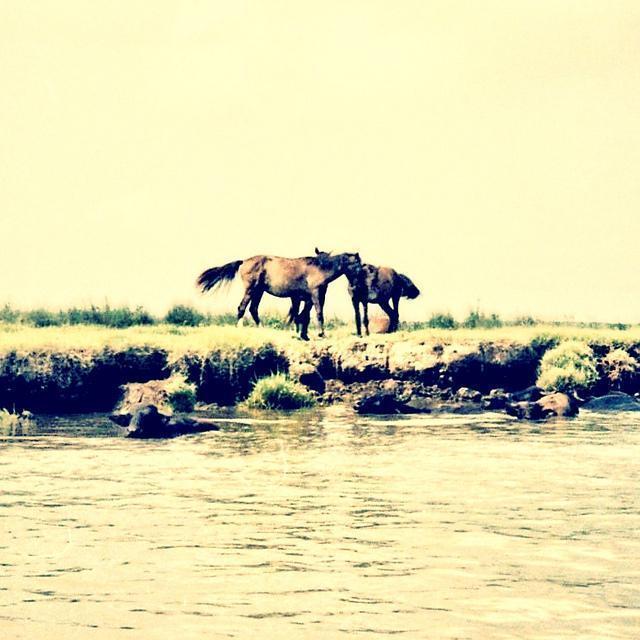How do the horses likely feel towards each other?
Select the correct answer and articulate reasoning with the following format: 'Answer: answer
Rationale: rationale.'
Options: Anxious, threatened, friendly, angry. Answer: friendly.
Rationale: The horses are rubbing each other affectionately. 